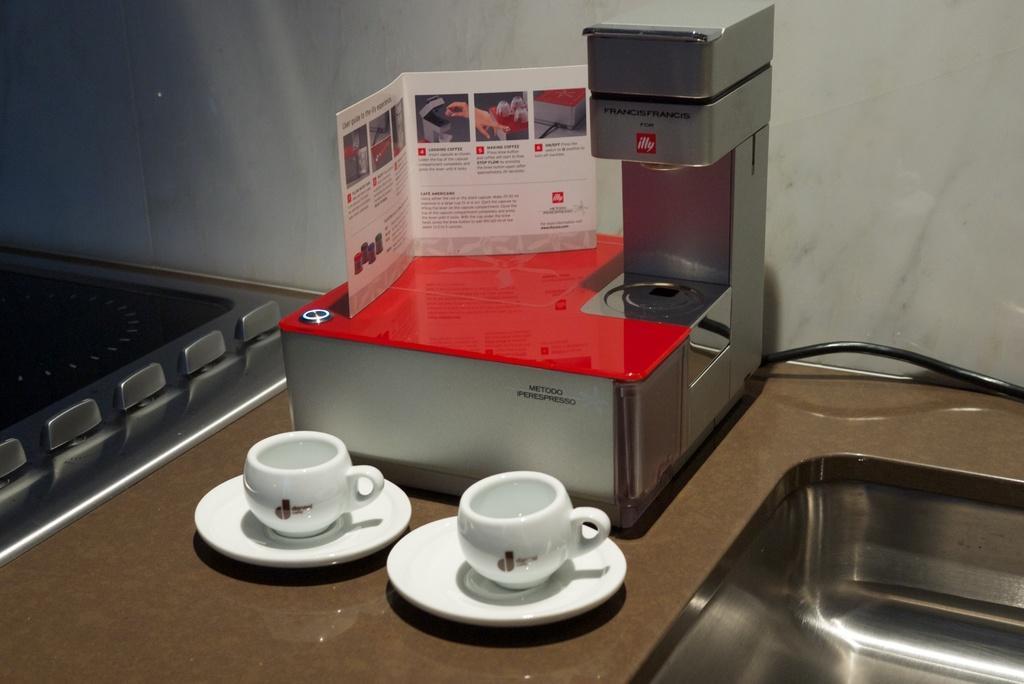How would you summarize this image in a sentence or two? In this image there is a table and we can see cups, saucers, sink, coffee maker, paper and an induction stove placed on the table. In the background there is a wall. 